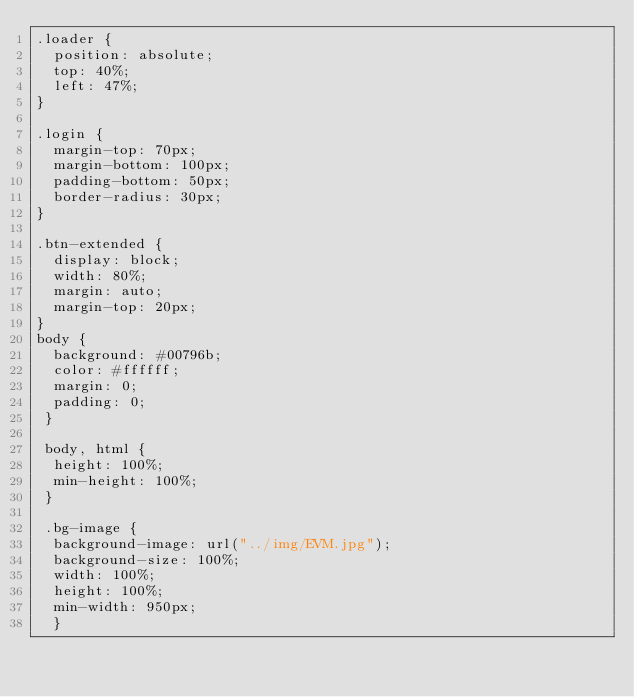Convert code to text. <code><loc_0><loc_0><loc_500><loc_500><_CSS_>.loader {
  position: absolute;
  top: 40%;
  left: 47%;
}

.login {
  margin-top: 70px;
  margin-bottom: 100px;
  padding-bottom: 50px;
  border-radius: 30px;
}

.btn-extended {
  display: block;
  width: 80%;
  margin: auto;
  margin-top: 20px;
}
body {
  background: #00796b;
  color: #ffffff;
  margin: 0;  
  padding: 0;
 }

 body, html {
  height: 100%;
  min-height: 100%;
 }

 .bg-image {
  background-image: url("../img/EVM.jpg");
  background-size: 100%;
  width: 100%;
  height: 100%;
  min-width: 950px;
  }</code> 